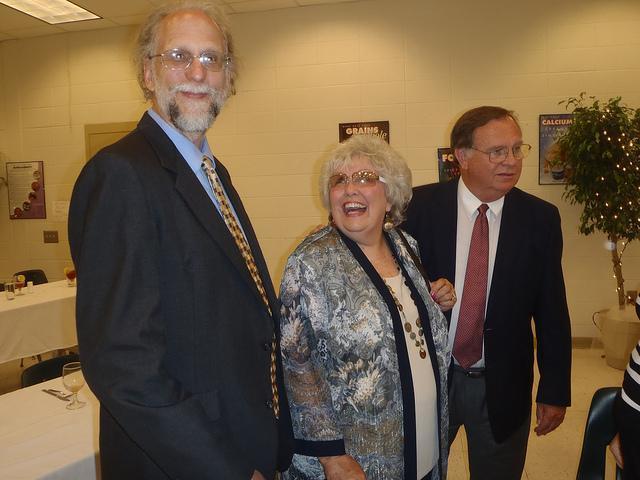How many men do you see?
Give a very brief answer. 2. How many people are wearing glasses?
Give a very brief answer. 3. How many men?
Give a very brief answer. 2. How many people are there?
Give a very brief answer. 4. How many chairs can be seen?
Give a very brief answer. 1. 